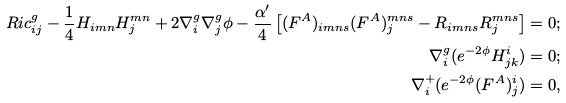<formula> <loc_0><loc_0><loc_500><loc_500>R i c ^ { g } _ { i j } - \frac { 1 } { 4 } H _ { i m n } H _ { j } ^ { m n } + 2 \nabla ^ { g } _ { i } \nabla ^ { g } _ { j } \phi - \frac { \alpha ^ { \prime } } 4 \left [ ( F ^ { A } ) _ { i m n s } ( F ^ { A } ) _ { j } ^ { m n s } - R _ { i m n s } R _ { j } ^ { m n s } \right ] = 0 ; \\ \nabla ^ { g } _ { i } ( e ^ { - 2 \phi } H ^ { i } _ { j k } ) = 0 ; \\ \nabla ^ { + } _ { i } ( e ^ { - 2 \phi } ( F ^ { A } ) ^ { i } _ { j } ) = 0 ,</formula> 